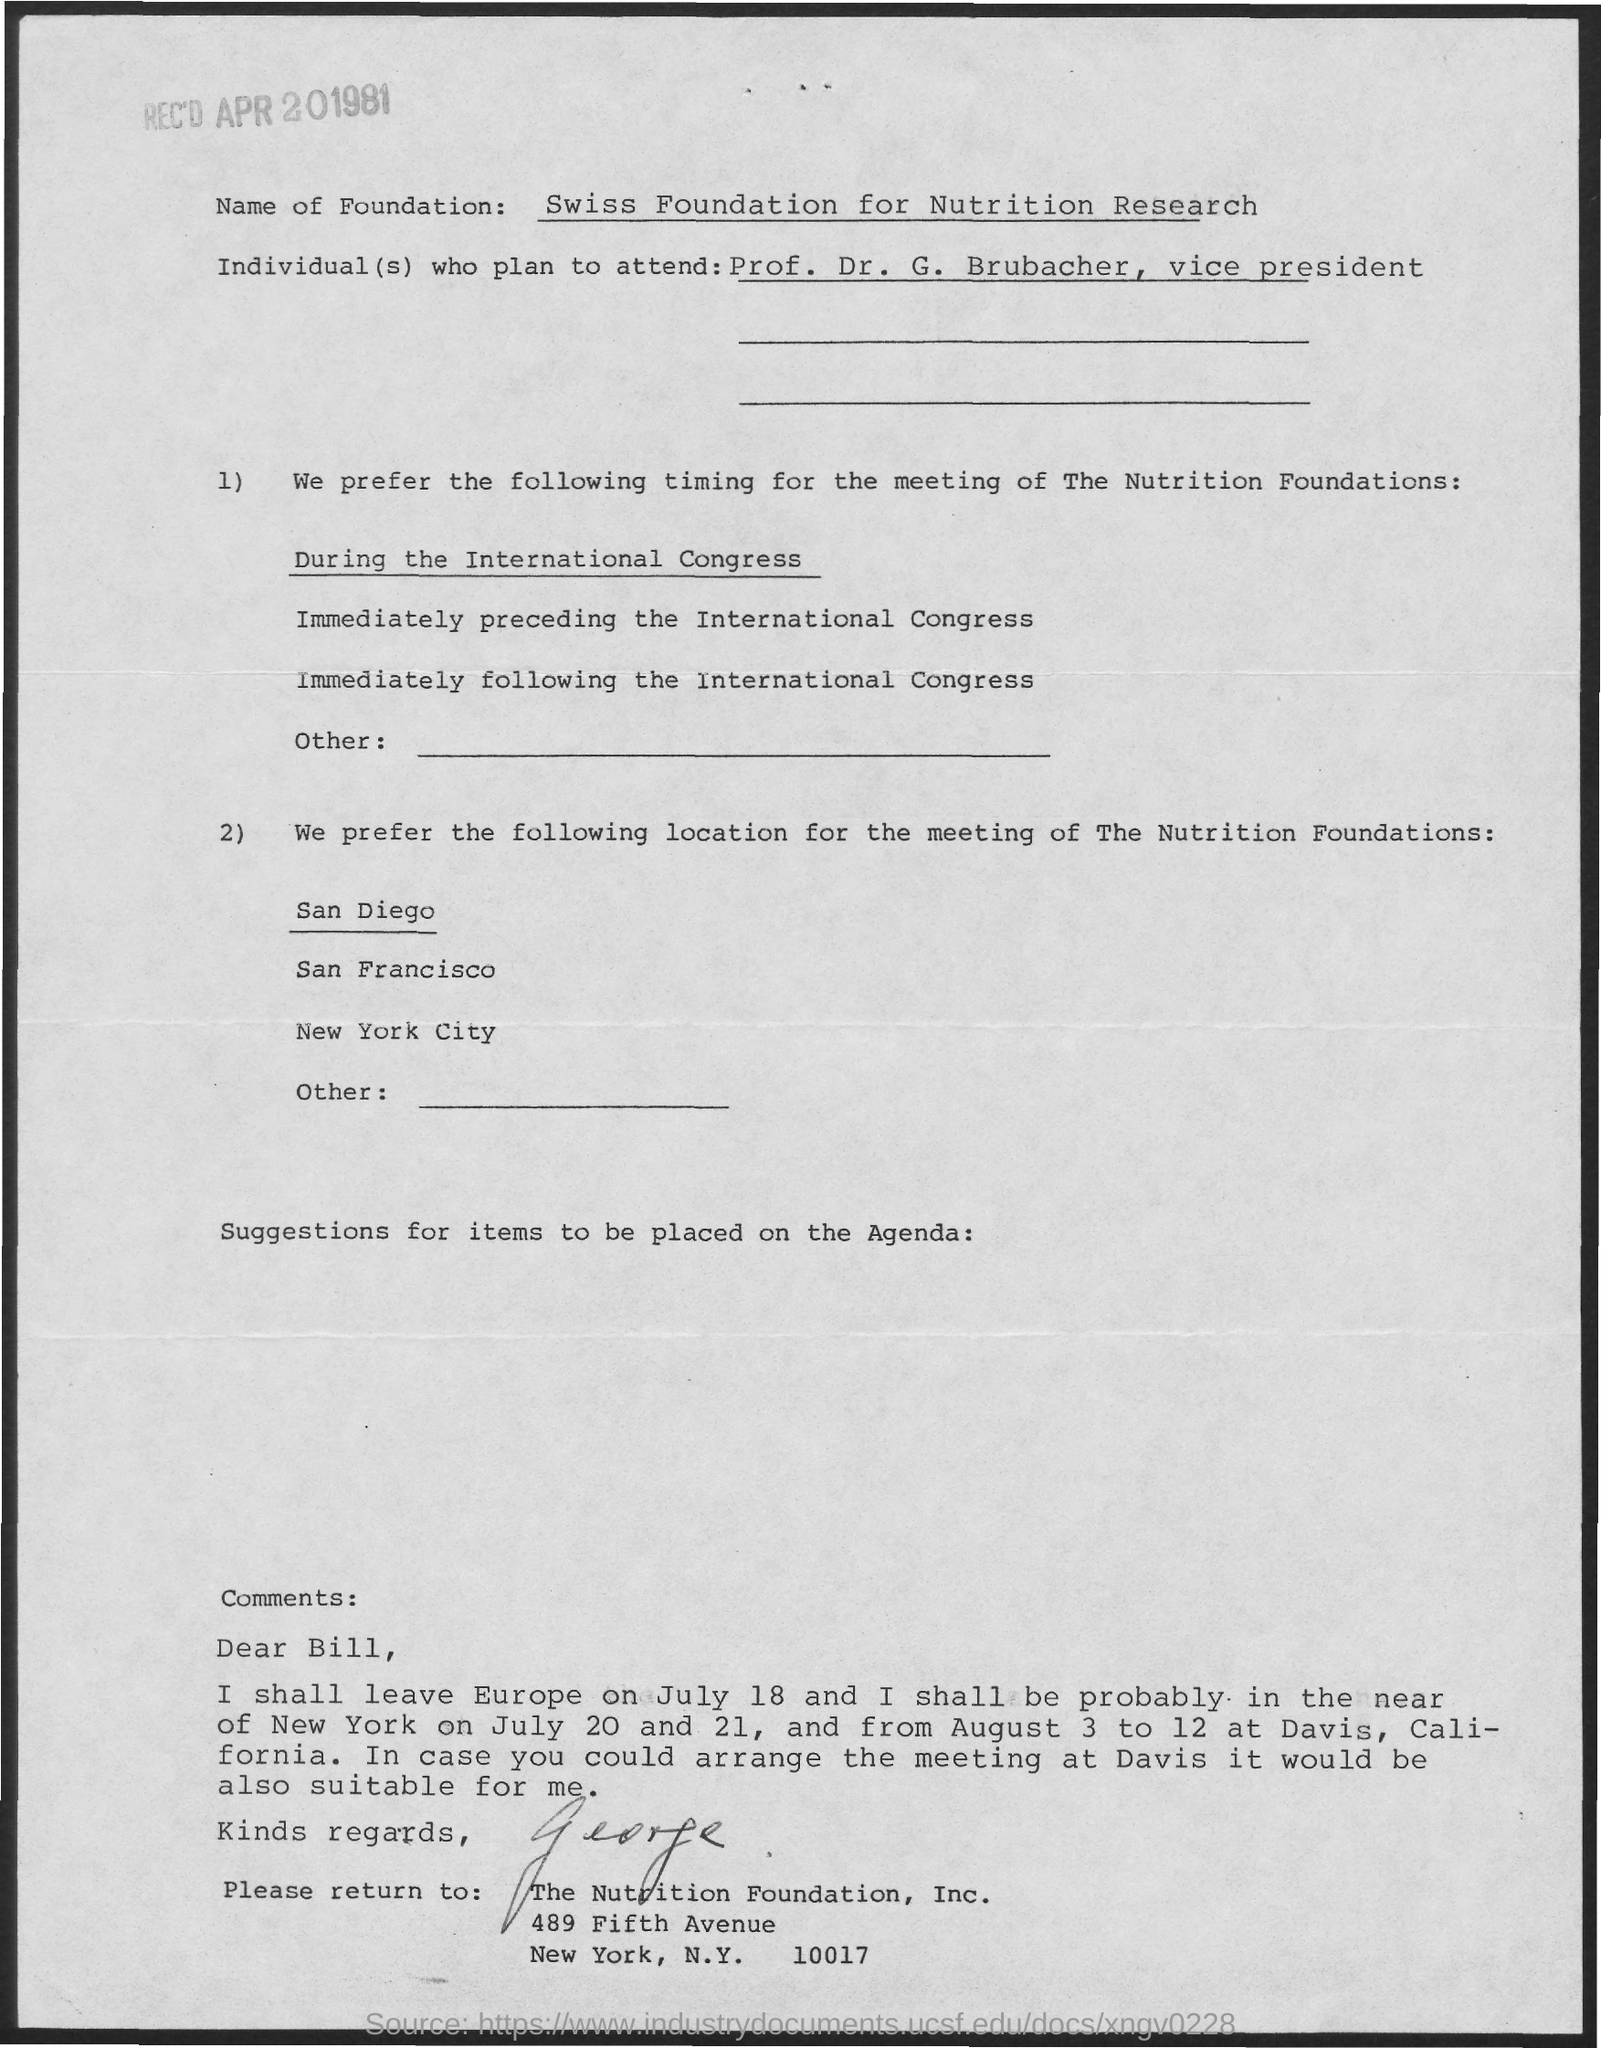Outline some significant characteristics in this image. The name of the foundation is the SWISS FOUNDATION FOR NUTRITION RESEARCH. 